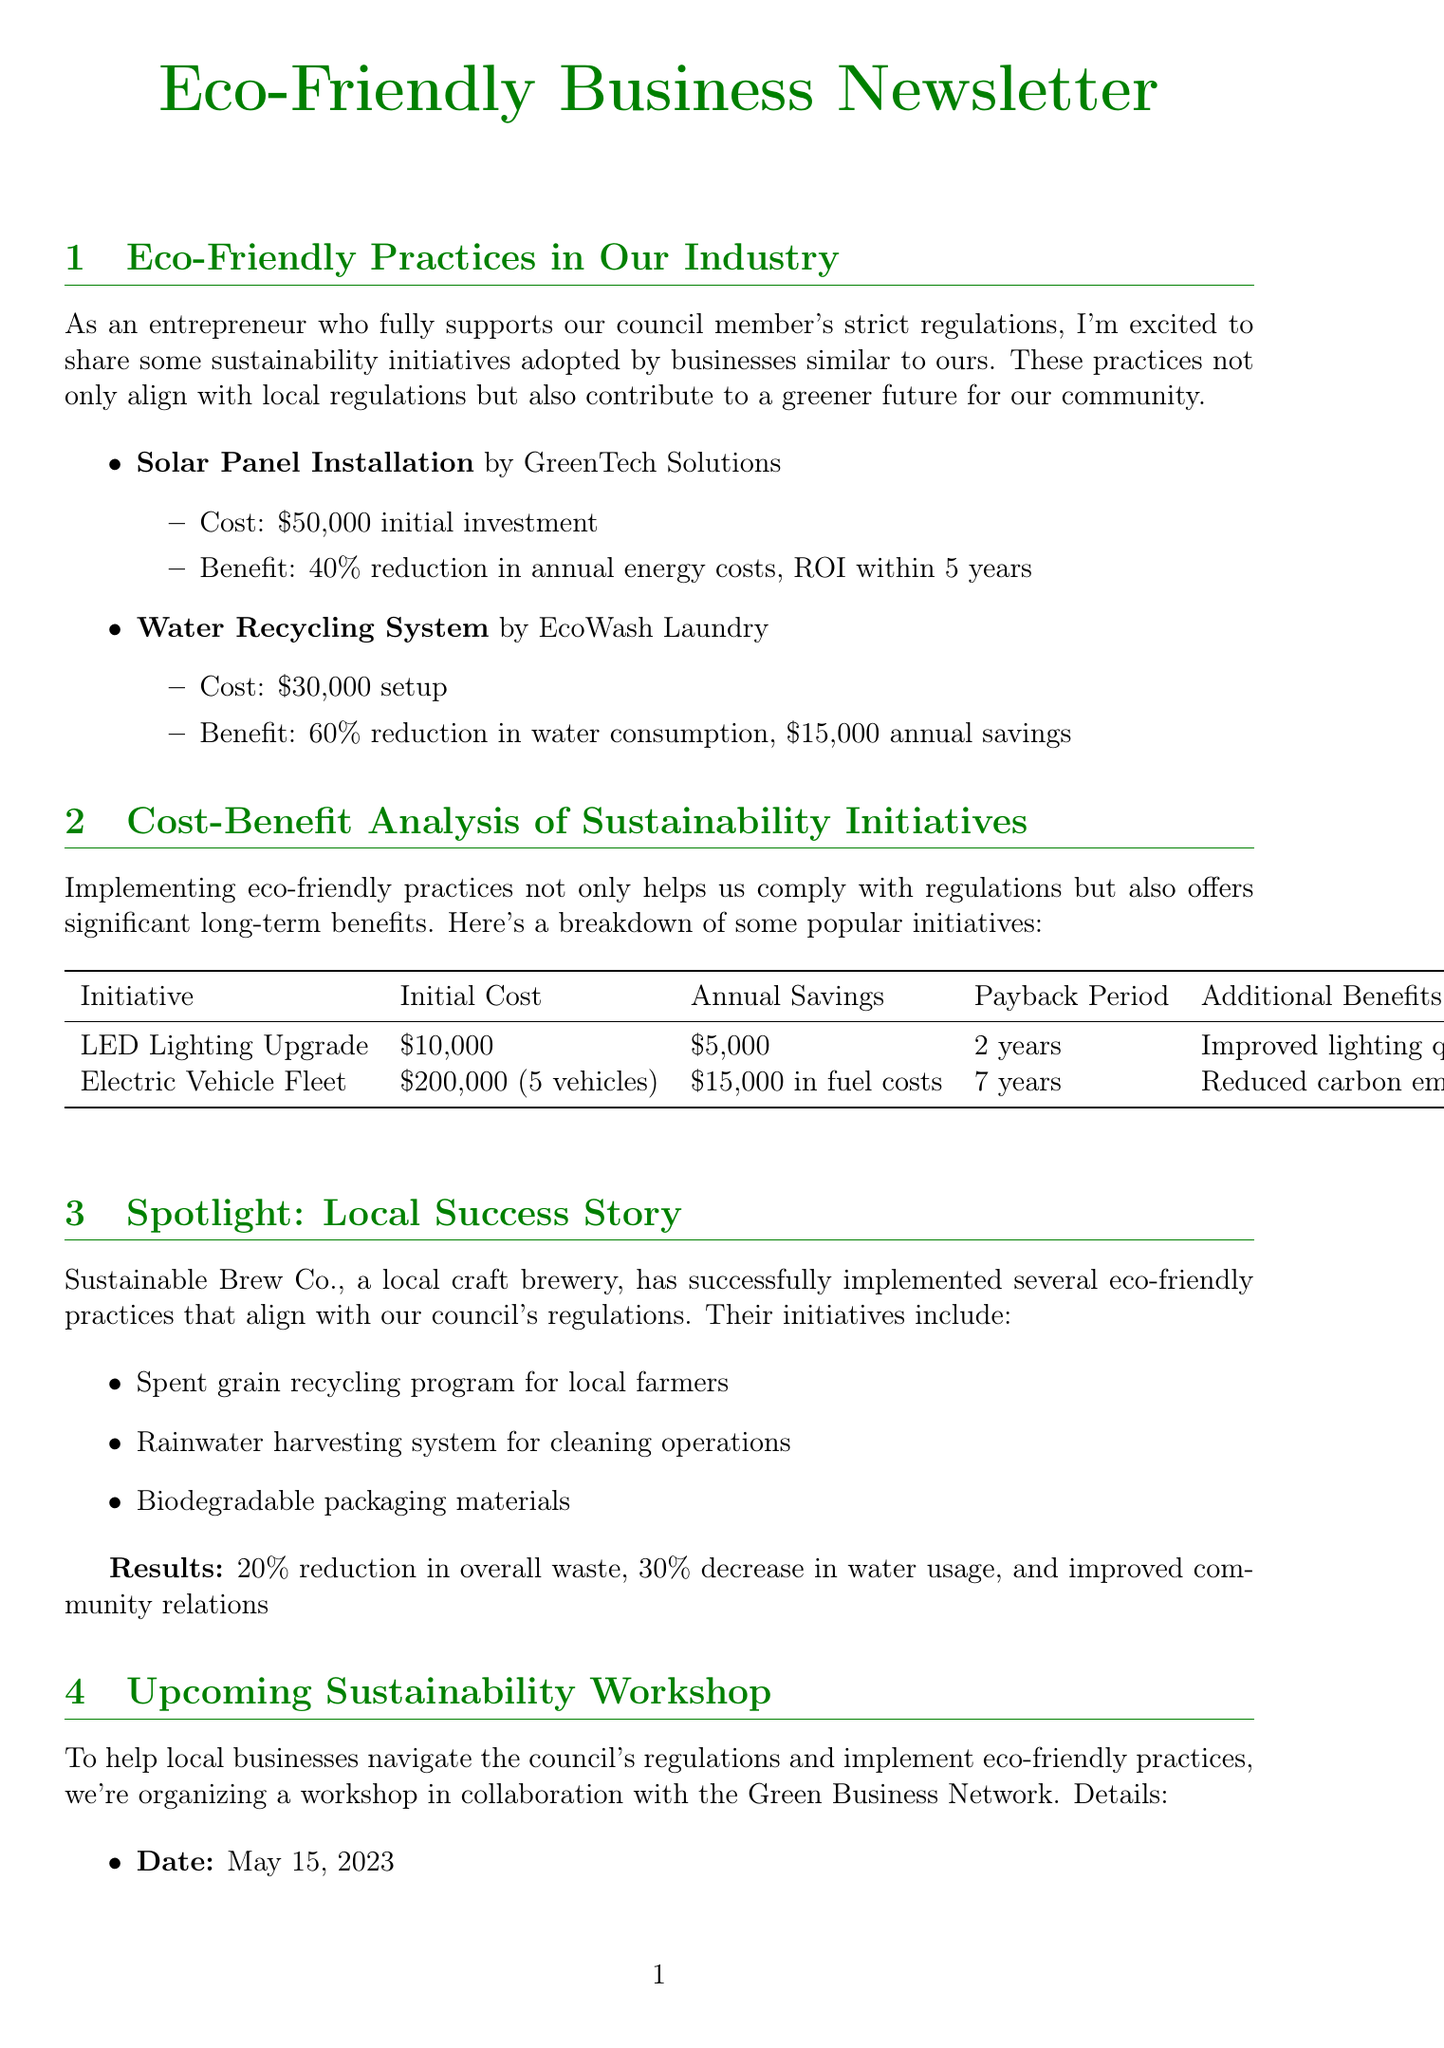What is the initial investment for the solar panel installation? The initial investment is mentioned in the eco-friendly practices section for solar panel installation by GreenTech Solutions.
Answer: $50,000 What percentage reduction in water consumption does the water recycling system provide? The percentage reduction for the water recycling system is specified in the eco-friendly practices section for EcoWash Laundry.
Answer: 60% What is the payback period for the LED lighting upgrade? The payback period is stated in the cost-benefit analysis section for the LED lighting upgrade initiative.
Answer: 2 years What date is the upcoming sustainability workshop scheduled for? The date of the workshop is explicitly mentioned in the upcoming sustainability workshop section.
Answer: May 15, 2023 Which company has implemented a spent grain recycling program? The company mentioned in the spotlight section that has this program is Sustainable Brew Co.
Answer: Sustainable Brew Co How much annual savings does the electric vehicle fleet initiative provide? The annual savings for the electric vehicle fleet is listed in the cost-benefit analysis section.
Answer: $15,000 What specific aspect of the LED lighting upgrade provides additional benefits? The additional benefits specified include improved lighting quality and longer bulb lifespan in the cost-benefit analysis section.
Answer: Improved lighting quality, longer bulb lifespan Who are the speakers at the sustainability workshop? The names of speakers listed in the upcoming workshop section need to be provided.
Answer: Emma Green, John Rivers, Sarah Solar 